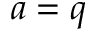Convert formula to latex. <formula><loc_0><loc_0><loc_500><loc_500>a = q</formula> 